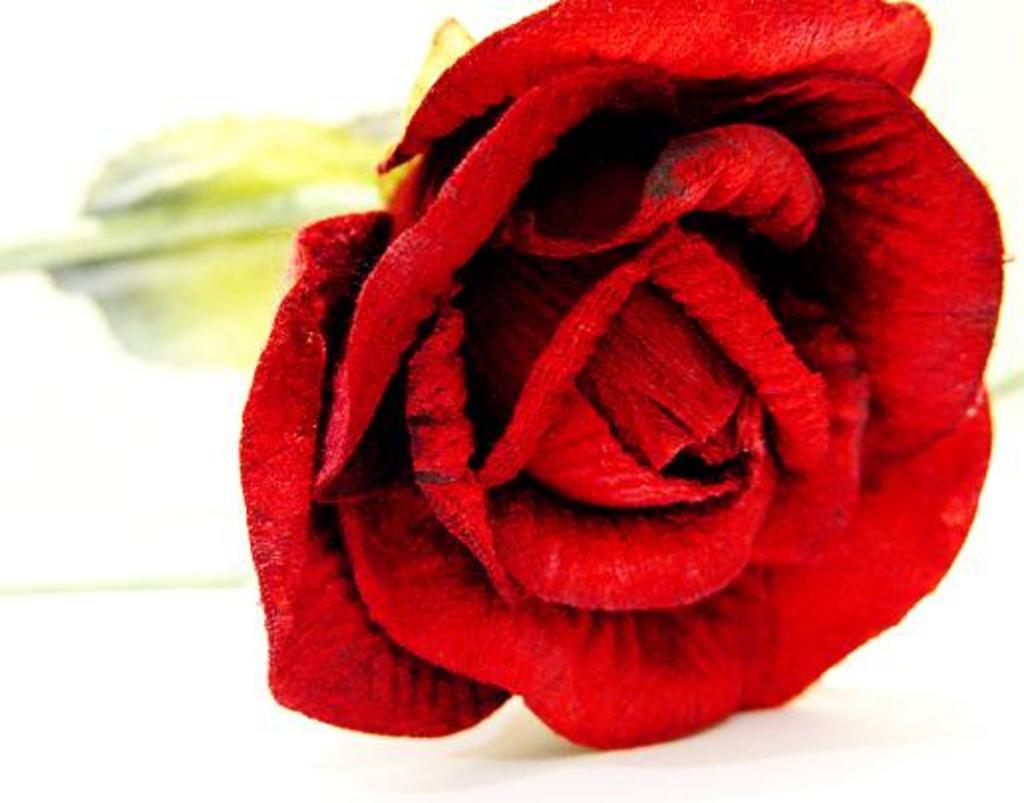What type of flower is in the image? There is a red rose in the image. What is the red rose placed on? The red rose is on a white platform. Can you describe the background of the image? The background of the image is blurry. What chess piece is missing from the image? There is no chess piece or chess set present in the image. How many members are on the committee in the image? There is no committee or any indication of a group of people in the image. 